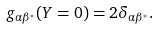<formula> <loc_0><loc_0><loc_500><loc_500>g _ { \alpha \beta ^ { * } } ( Y = 0 ) = 2 \delta _ { \alpha \beta ^ { * } } .</formula> 